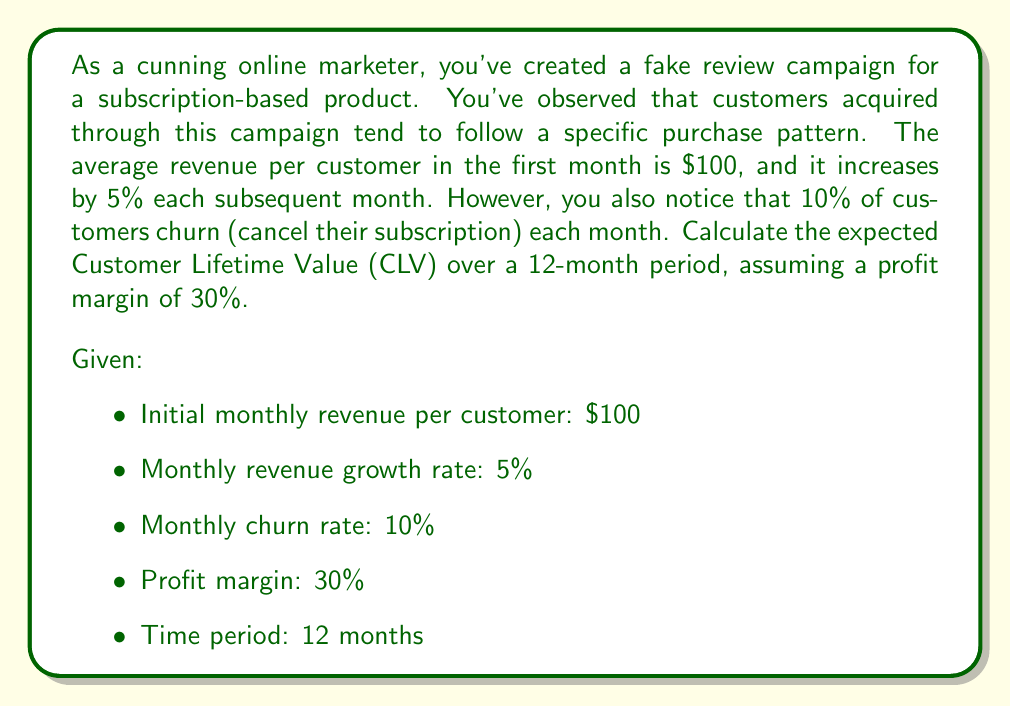Can you answer this question? To solve this problem, we need to calculate the expected revenue for each month, considering both the growth in revenue and the churn rate, and then sum up the profits over the 12-month period.

Let's break it down step by step:

1) First, let's define our series:
   $R_n$ = Revenue per customer in month $n$
   $C_n$ = Proportion of customers remaining in month $n$

2) We can express these series as:
   $R_n = 100 \cdot (1.05)^{n-1}$ (starts at 100 and grows by 5% each month)
   $C_n = (0.9)^{n-1}$ (starts at 1 and decreases by 10% each month)

3) The expected revenue for month $n$ is $R_n \cdot C_n$

4) The profit for month $n$ is 30% of the revenue: $0.3 \cdot R_n \cdot C_n$

5) The total CLV over 12 months is the sum of these profits:

   $$CLV = \sum_{n=1}^{12} 0.3 \cdot R_n \cdot C_n$$

6) Expanding this sum:

   $$CLV = 0.3 \cdot \sum_{n=1}^{12} 100 \cdot (1.05)^{n-1} \cdot (0.9)^{n-1}$$

7) Simplifying:

   $$CLV = 30 \cdot \sum_{n=1}^{12} (0.945)^{n-1}$$

8) This is a geometric series with first term $a = 30$ and common ratio $r = 0.945$

9) The sum of a geometric series is given by the formula:
   $$S_n = a \cdot \frac{1-r^n}{1-r}$$

10) Plugging in our values:

    $$CLV = 30 \cdot \frac{1-(0.945)^{12}}{1-0.945}$$

11) Calculating this:
    $$CLV = 30 \cdot \frac{1-0.5188}{0.055} = 30 \cdot 8.7491 = 262.47$$

Therefore, the expected Customer Lifetime Value over a 12-month period is $262.47.
Answer: $262.47 